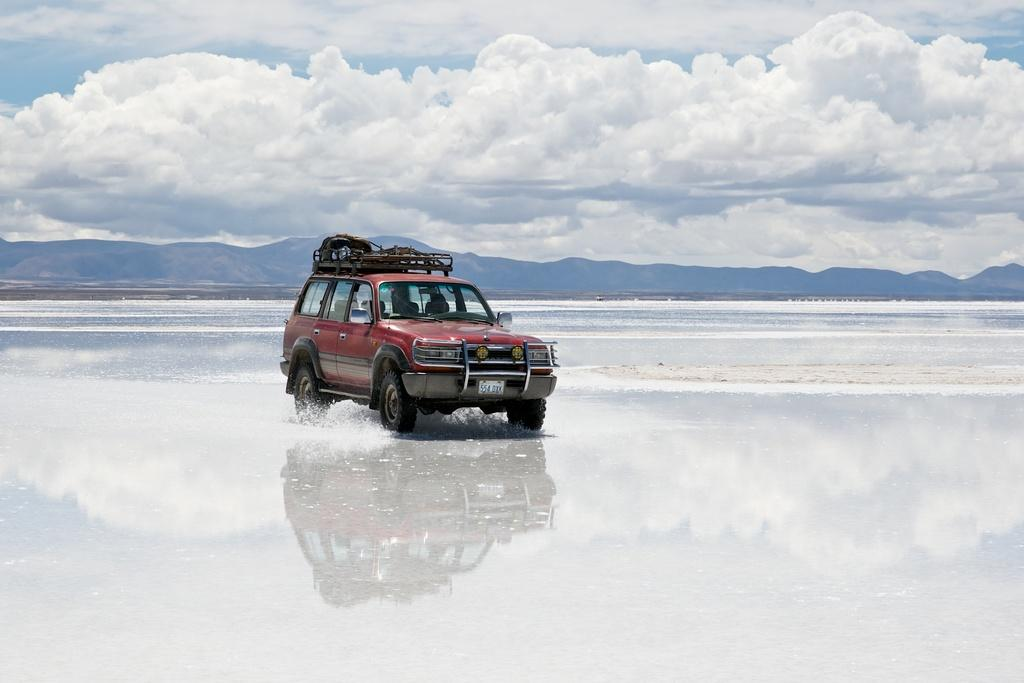What is present in the image besides the car? There is water visible in the image. Can you describe the car in the image? The car is red and is in the middle of the image. What can be seen in the background of the image? The sky is visible in the background of the image. How would you describe the weather based on the image? The sky is cloudy, which suggests a partly cloudy or overcast day. How many clovers are growing in the water in the image? There are no clovers present in the image; it features a red car and water. What type of elbow is visible in the image? There is no elbow present in the image. 